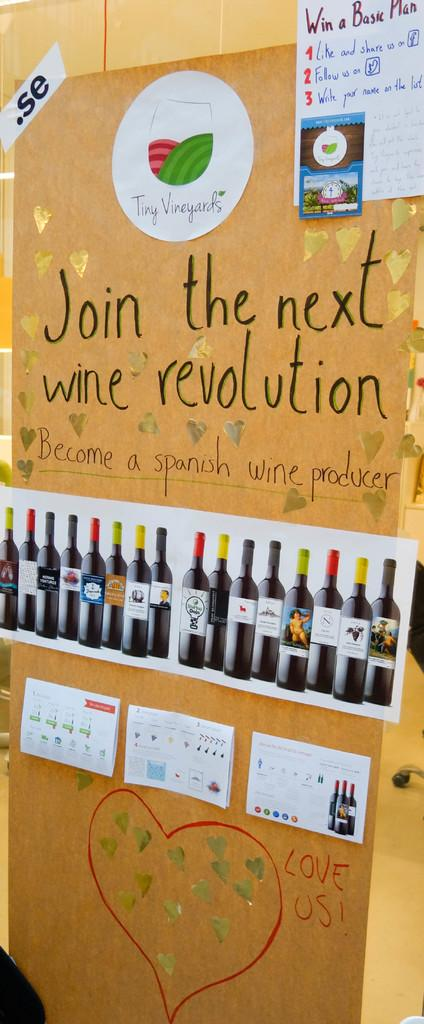Provide a one-sentence caption for the provided image. A display advertises for people to join the next wine revolution. 